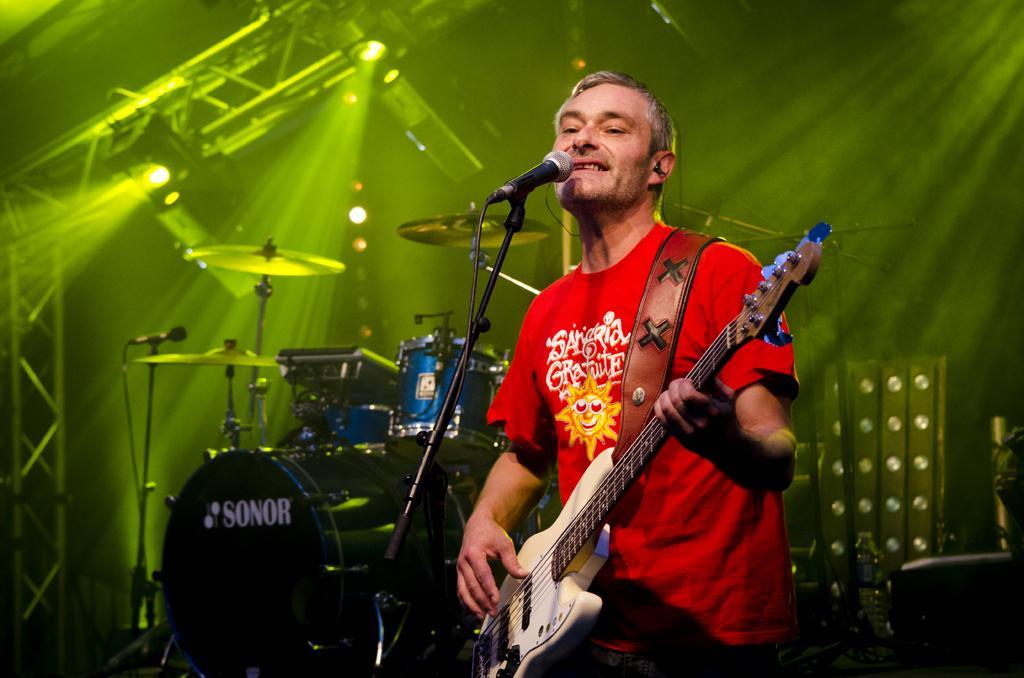Please provide a concise description of this image. In this picture there is a person sitting and holding guitar. There is microphone with stand. There are drum plates and there are drum. On the top we can see focusing lights. 